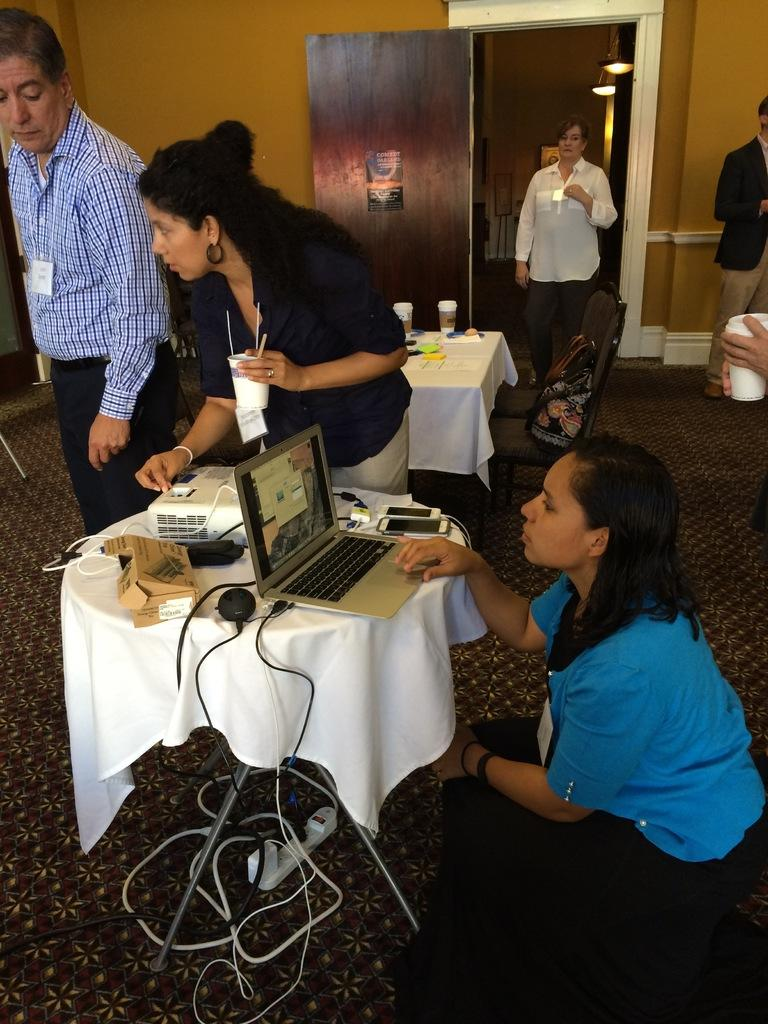What type of structure can be seen in the image? There is a wall in the image. Is there any entrance visible in the image? Yes, there is a door in the image. Who or what is present in the image? There are people standing in the image. What furniture is in the image? There is a table in the image. What electronic devices are on the table? There is a laptop and mobile phones on the table. What color is the sweater worn by the baseball player in the image? There is no baseball player or sweater present in the image. What type of paper is being used by the people in the image? There is no paper visible in the image. 